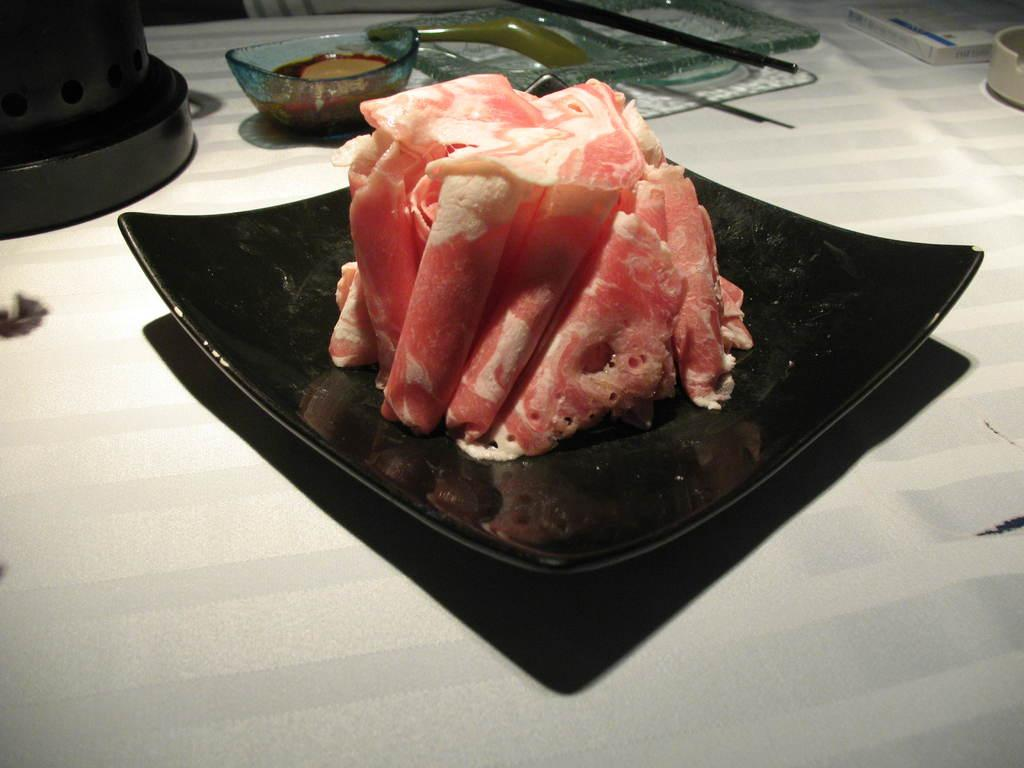What is the main food item visible on the table in the image? There is a food item on the table, but the specific type cannot be determined from the provided facts. How is the food item in the bowl being served? The food item in the bowl is being served in a bowl, but the specific type and presentation cannot be determined from the provided facts. What is the purpose of the tray in the image? The purpose of the tray in the image cannot be determined from the provided facts. What other objects can be seen on the surface in the image? There are other objects on a surface in the image, but their specific types cannot be determined from the provided facts. What type of crime is being committed in the downtown area in the image? There is no mention of a downtown area or any crime in the image, so this question cannot be answered. 